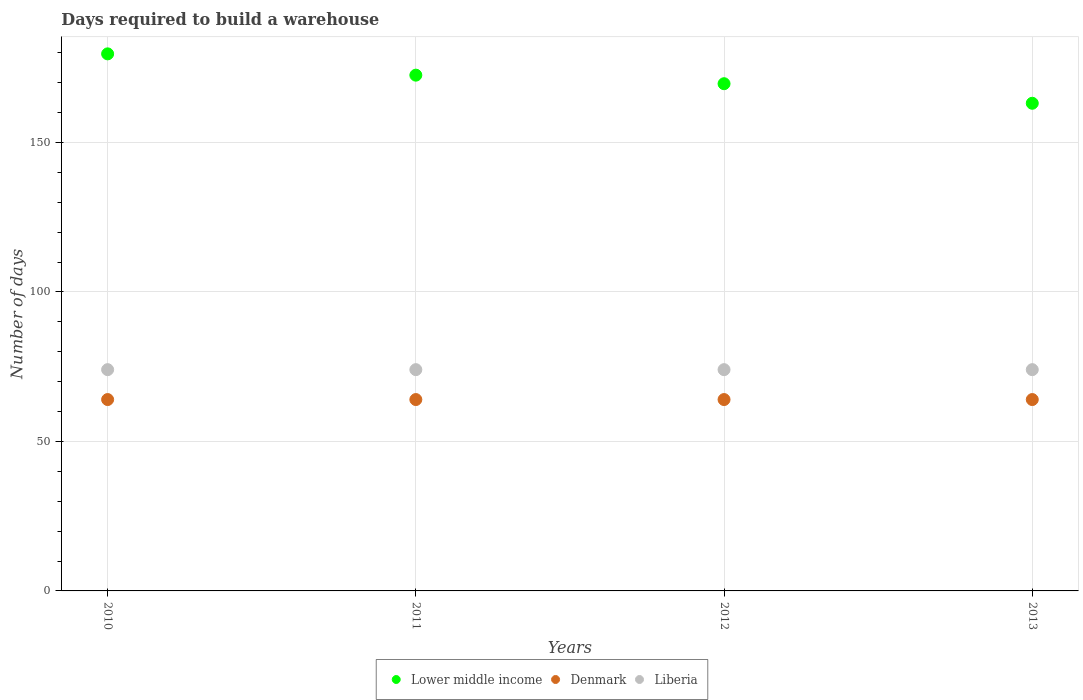How many different coloured dotlines are there?
Ensure brevity in your answer.  3. Is the number of dotlines equal to the number of legend labels?
Provide a succinct answer. Yes. What is the days required to build a warehouse in in Lower middle income in 2011?
Your answer should be compact. 172.49. Across all years, what is the maximum days required to build a warehouse in in Lower middle income?
Your answer should be very brief. 179.61. Across all years, what is the minimum days required to build a warehouse in in Liberia?
Make the answer very short. 74. In which year was the days required to build a warehouse in in Liberia maximum?
Ensure brevity in your answer.  2010. What is the total days required to build a warehouse in in Liberia in the graph?
Offer a terse response. 296. What is the difference between the days required to build a warehouse in in Denmark in 2010 and that in 2011?
Offer a terse response. 0. What is the difference between the days required to build a warehouse in in Denmark in 2013 and the days required to build a warehouse in in Lower middle income in 2012?
Your answer should be compact. -105.63. What is the average days required to build a warehouse in in Liberia per year?
Your answer should be compact. 74. In the year 2012, what is the difference between the days required to build a warehouse in in Liberia and days required to build a warehouse in in Denmark?
Ensure brevity in your answer.  10. What is the ratio of the days required to build a warehouse in in Lower middle income in 2011 to that in 2012?
Provide a succinct answer. 1.02. What is the difference between the highest and the lowest days required to build a warehouse in in Liberia?
Make the answer very short. 0. In how many years, is the days required to build a warehouse in in Liberia greater than the average days required to build a warehouse in in Liberia taken over all years?
Provide a short and direct response. 0. Is the sum of the days required to build a warehouse in in Denmark in 2011 and 2012 greater than the maximum days required to build a warehouse in in Lower middle income across all years?
Keep it short and to the point. No. Does the days required to build a warehouse in in Liberia monotonically increase over the years?
Provide a succinct answer. No. Is the days required to build a warehouse in in Lower middle income strictly greater than the days required to build a warehouse in in Denmark over the years?
Your answer should be very brief. Yes. What is the difference between two consecutive major ticks on the Y-axis?
Your answer should be very brief. 50. Are the values on the major ticks of Y-axis written in scientific E-notation?
Your answer should be compact. No. Does the graph contain grids?
Provide a succinct answer. Yes. Where does the legend appear in the graph?
Offer a very short reply. Bottom center. How are the legend labels stacked?
Offer a terse response. Horizontal. What is the title of the graph?
Provide a short and direct response. Days required to build a warehouse. Does "Pakistan" appear as one of the legend labels in the graph?
Your response must be concise. No. What is the label or title of the Y-axis?
Keep it short and to the point. Number of days. What is the Number of days of Lower middle income in 2010?
Provide a short and direct response. 179.61. What is the Number of days in Denmark in 2010?
Your answer should be very brief. 64. What is the Number of days of Liberia in 2010?
Your response must be concise. 74. What is the Number of days in Lower middle income in 2011?
Offer a terse response. 172.49. What is the Number of days of Denmark in 2011?
Offer a terse response. 64. What is the Number of days in Liberia in 2011?
Your answer should be compact. 74. What is the Number of days in Lower middle income in 2012?
Your answer should be compact. 169.63. What is the Number of days in Lower middle income in 2013?
Your answer should be compact. 163.09. What is the Number of days in Denmark in 2013?
Your response must be concise. 64. Across all years, what is the maximum Number of days in Lower middle income?
Provide a succinct answer. 179.61. Across all years, what is the maximum Number of days in Denmark?
Keep it short and to the point. 64. Across all years, what is the maximum Number of days in Liberia?
Your response must be concise. 74. Across all years, what is the minimum Number of days in Lower middle income?
Make the answer very short. 163.09. Across all years, what is the minimum Number of days in Liberia?
Provide a succinct answer. 74. What is the total Number of days of Lower middle income in the graph?
Keep it short and to the point. 684.82. What is the total Number of days of Denmark in the graph?
Your response must be concise. 256. What is the total Number of days in Liberia in the graph?
Give a very brief answer. 296. What is the difference between the Number of days in Lower middle income in 2010 and that in 2011?
Give a very brief answer. 7.12. What is the difference between the Number of days of Liberia in 2010 and that in 2011?
Make the answer very short. 0. What is the difference between the Number of days in Lower middle income in 2010 and that in 2012?
Offer a terse response. 9.98. What is the difference between the Number of days in Liberia in 2010 and that in 2012?
Make the answer very short. 0. What is the difference between the Number of days in Lower middle income in 2010 and that in 2013?
Keep it short and to the point. 16.52. What is the difference between the Number of days of Lower middle income in 2011 and that in 2012?
Provide a succinct answer. 2.86. What is the difference between the Number of days in Lower middle income in 2011 and that in 2013?
Your answer should be very brief. 9.4. What is the difference between the Number of days in Denmark in 2011 and that in 2013?
Your response must be concise. 0. What is the difference between the Number of days in Lower middle income in 2012 and that in 2013?
Keep it short and to the point. 6.54. What is the difference between the Number of days of Liberia in 2012 and that in 2013?
Ensure brevity in your answer.  0. What is the difference between the Number of days in Lower middle income in 2010 and the Number of days in Denmark in 2011?
Ensure brevity in your answer.  115.61. What is the difference between the Number of days in Lower middle income in 2010 and the Number of days in Liberia in 2011?
Offer a terse response. 105.61. What is the difference between the Number of days of Lower middle income in 2010 and the Number of days of Denmark in 2012?
Offer a very short reply. 115.61. What is the difference between the Number of days of Lower middle income in 2010 and the Number of days of Liberia in 2012?
Keep it short and to the point. 105.61. What is the difference between the Number of days in Lower middle income in 2010 and the Number of days in Denmark in 2013?
Your response must be concise. 115.61. What is the difference between the Number of days of Lower middle income in 2010 and the Number of days of Liberia in 2013?
Your answer should be compact. 105.61. What is the difference between the Number of days in Lower middle income in 2011 and the Number of days in Denmark in 2012?
Your answer should be compact. 108.49. What is the difference between the Number of days in Lower middle income in 2011 and the Number of days in Liberia in 2012?
Provide a succinct answer. 98.49. What is the difference between the Number of days of Lower middle income in 2011 and the Number of days of Denmark in 2013?
Offer a very short reply. 108.49. What is the difference between the Number of days of Lower middle income in 2011 and the Number of days of Liberia in 2013?
Your answer should be very brief. 98.49. What is the difference between the Number of days of Lower middle income in 2012 and the Number of days of Denmark in 2013?
Offer a very short reply. 105.63. What is the difference between the Number of days in Lower middle income in 2012 and the Number of days in Liberia in 2013?
Make the answer very short. 95.63. What is the average Number of days in Lower middle income per year?
Provide a succinct answer. 171.2. In the year 2010, what is the difference between the Number of days of Lower middle income and Number of days of Denmark?
Provide a short and direct response. 115.61. In the year 2010, what is the difference between the Number of days in Lower middle income and Number of days in Liberia?
Ensure brevity in your answer.  105.61. In the year 2010, what is the difference between the Number of days of Denmark and Number of days of Liberia?
Your response must be concise. -10. In the year 2011, what is the difference between the Number of days of Lower middle income and Number of days of Denmark?
Provide a succinct answer. 108.49. In the year 2011, what is the difference between the Number of days in Lower middle income and Number of days in Liberia?
Your response must be concise. 98.49. In the year 2012, what is the difference between the Number of days in Lower middle income and Number of days in Denmark?
Your answer should be compact. 105.63. In the year 2012, what is the difference between the Number of days of Lower middle income and Number of days of Liberia?
Provide a succinct answer. 95.63. In the year 2013, what is the difference between the Number of days of Lower middle income and Number of days of Denmark?
Offer a very short reply. 99.09. In the year 2013, what is the difference between the Number of days of Lower middle income and Number of days of Liberia?
Provide a short and direct response. 89.09. In the year 2013, what is the difference between the Number of days of Denmark and Number of days of Liberia?
Keep it short and to the point. -10. What is the ratio of the Number of days of Lower middle income in 2010 to that in 2011?
Provide a succinct answer. 1.04. What is the ratio of the Number of days in Denmark in 2010 to that in 2011?
Keep it short and to the point. 1. What is the ratio of the Number of days in Liberia in 2010 to that in 2011?
Give a very brief answer. 1. What is the ratio of the Number of days of Lower middle income in 2010 to that in 2012?
Your answer should be very brief. 1.06. What is the ratio of the Number of days of Liberia in 2010 to that in 2012?
Your response must be concise. 1. What is the ratio of the Number of days of Lower middle income in 2010 to that in 2013?
Offer a terse response. 1.1. What is the ratio of the Number of days of Lower middle income in 2011 to that in 2012?
Keep it short and to the point. 1.02. What is the ratio of the Number of days in Liberia in 2011 to that in 2012?
Your answer should be compact. 1. What is the ratio of the Number of days in Lower middle income in 2011 to that in 2013?
Provide a short and direct response. 1.06. What is the ratio of the Number of days in Denmark in 2011 to that in 2013?
Offer a terse response. 1. What is the ratio of the Number of days of Lower middle income in 2012 to that in 2013?
Your answer should be compact. 1.04. What is the ratio of the Number of days in Denmark in 2012 to that in 2013?
Keep it short and to the point. 1. What is the ratio of the Number of days of Liberia in 2012 to that in 2013?
Provide a short and direct response. 1. What is the difference between the highest and the second highest Number of days of Lower middle income?
Offer a very short reply. 7.12. What is the difference between the highest and the second highest Number of days of Denmark?
Give a very brief answer. 0. What is the difference between the highest and the second highest Number of days in Liberia?
Keep it short and to the point. 0. What is the difference between the highest and the lowest Number of days in Lower middle income?
Give a very brief answer. 16.52. What is the difference between the highest and the lowest Number of days of Denmark?
Offer a terse response. 0. What is the difference between the highest and the lowest Number of days in Liberia?
Your response must be concise. 0. 